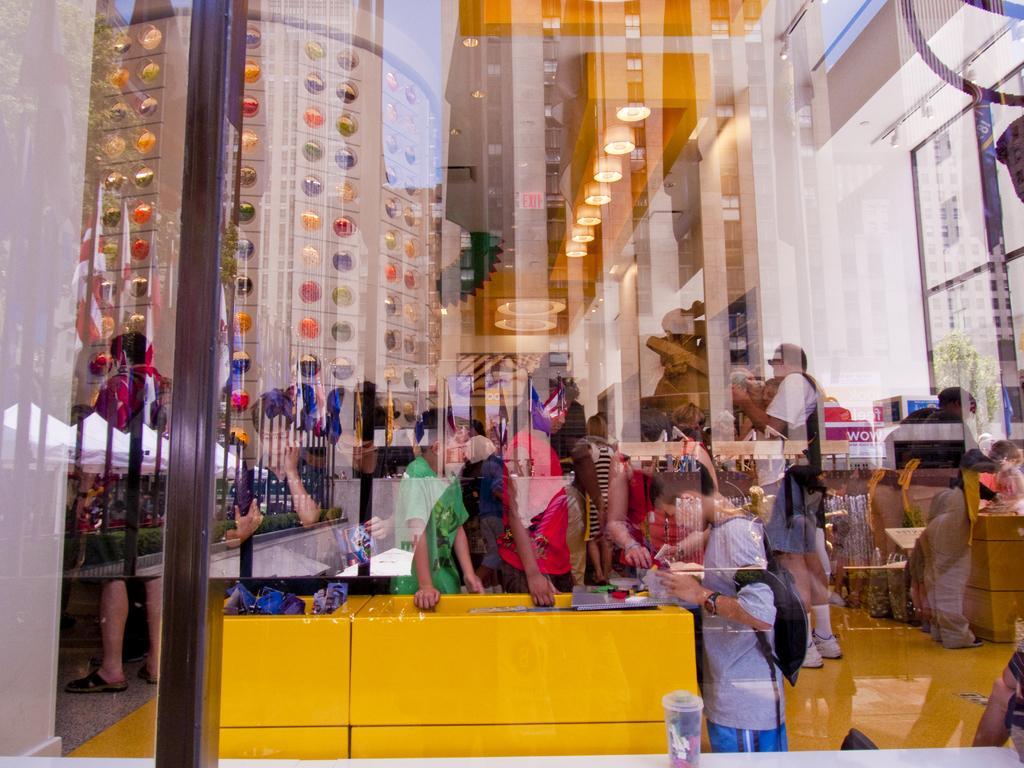In one or two sentences, can you explain what this image depicts? In this picture I can see there is a glass window and I can see there is a reflection of trees, buildings, flags attached to the flagpole and there are few kids at the table, people sitting on the chairs a wall with a design and lights which are behind the glass. 